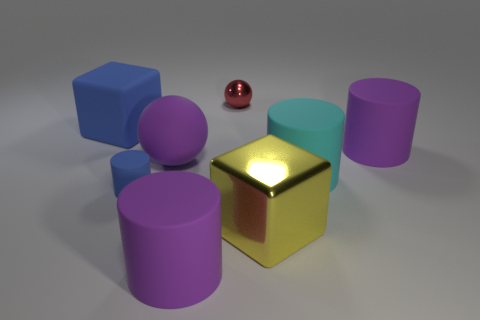Subtract all gray cylinders. Subtract all brown cubes. How many cylinders are left? 4 Add 1 big matte cylinders. How many objects exist? 9 Subtract all spheres. How many objects are left? 6 Subtract all large things. Subtract all small blue rubber balls. How many objects are left? 2 Add 5 big purple rubber things. How many big purple rubber things are left? 8 Add 7 large purple matte cylinders. How many large purple matte cylinders exist? 9 Subtract 0 gray cylinders. How many objects are left? 8 